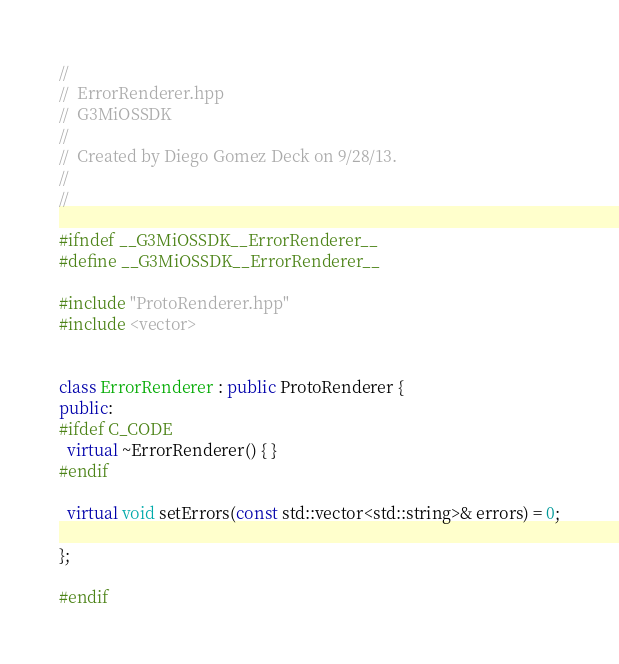<code> <loc_0><loc_0><loc_500><loc_500><_C++_>//
//  ErrorRenderer.hpp
//  G3MiOSSDK
//
//  Created by Diego Gomez Deck on 9/28/13.
//
//

#ifndef __G3MiOSSDK__ErrorRenderer__
#define __G3MiOSSDK__ErrorRenderer__

#include "ProtoRenderer.hpp"
#include <vector>


class ErrorRenderer : public ProtoRenderer {
public:
#ifdef C_CODE
  virtual ~ErrorRenderer() { }
#endif

  virtual void setErrors(const std::vector<std::string>& errors) = 0;

};

#endif
</code> 